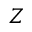<formula> <loc_0><loc_0><loc_500><loc_500>Z</formula> 